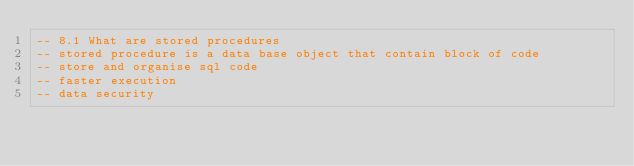<code> <loc_0><loc_0><loc_500><loc_500><_SQL_>-- 8.1 What are stored procedures
-- stored procedure is a data base object that contain block of code 
-- store and organise sql code
-- faster execution
-- data security </code> 